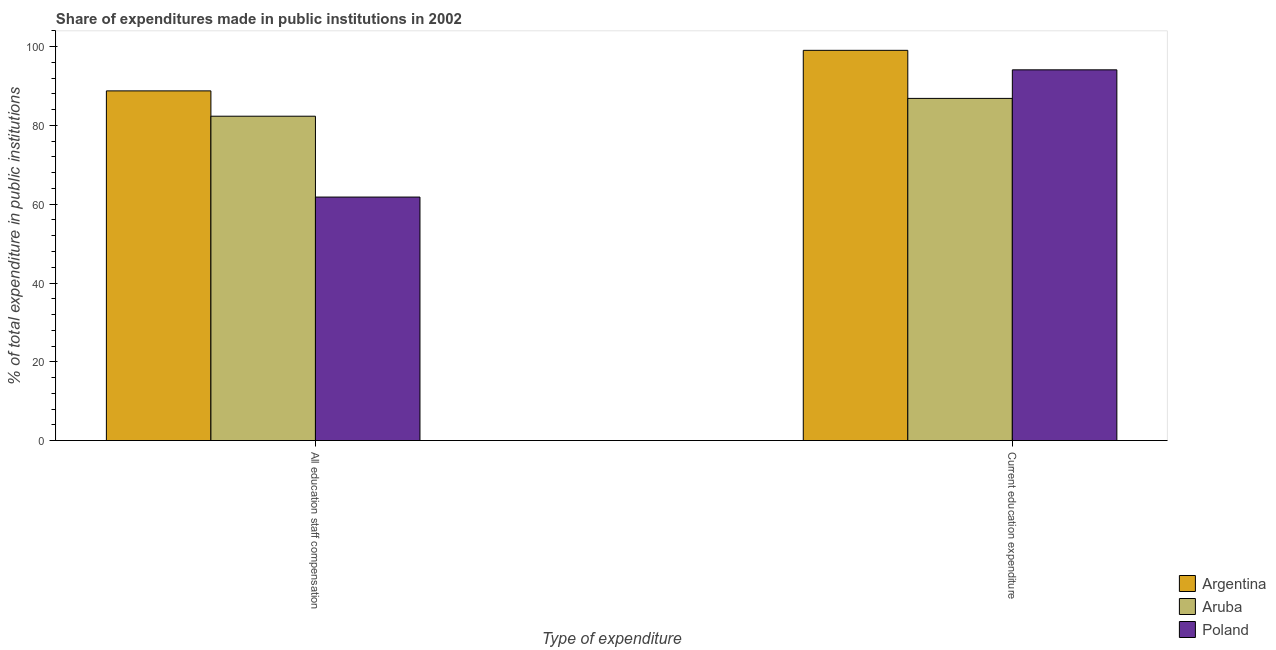How many different coloured bars are there?
Give a very brief answer. 3. How many bars are there on the 1st tick from the right?
Provide a short and direct response. 3. What is the label of the 2nd group of bars from the left?
Ensure brevity in your answer.  Current education expenditure. What is the expenditure in education in Argentina?
Ensure brevity in your answer.  99.06. Across all countries, what is the maximum expenditure in staff compensation?
Give a very brief answer. 88.77. Across all countries, what is the minimum expenditure in education?
Provide a succinct answer. 86.86. In which country was the expenditure in education maximum?
Keep it short and to the point. Argentina. In which country was the expenditure in education minimum?
Give a very brief answer. Aruba. What is the total expenditure in staff compensation in the graph?
Your answer should be very brief. 232.92. What is the difference between the expenditure in staff compensation in Poland and that in Argentina?
Give a very brief answer. -26.95. What is the difference between the expenditure in education in Poland and the expenditure in staff compensation in Aruba?
Make the answer very short. 11.77. What is the average expenditure in education per country?
Offer a very short reply. 93.34. What is the difference between the expenditure in staff compensation and expenditure in education in Argentina?
Your answer should be compact. -10.29. In how many countries, is the expenditure in education greater than 76 %?
Offer a terse response. 3. What is the ratio of the expenditure in education in Aruba to that in Argentina?
Your answer should be compact. 0.88. What does the 2nd bar from the right in Current education expenditure represents?
Your answer should be very brief. Aruba. How many bars are there?
Make the answer very short. 6. Are all the bars in the graph horizontal?
Your answer should be compact. No. What is the difference between two consecutive major ticks on the Y-axis?
Make the answer very short. 20. Are the values on the major ticks of Y-axis written in scientific E-notation?
Provide a succinct answer. No. How many legend labels are there?
Offer a terse response. 3. How are the legend labels stacked?
Make the answer very short. Vertical. What is the title of the graph?
Your response must be concise. Share of expenditures made in public institutions in 2002. What is the label or title of the X-axis?
Offer a very short reply. Type of expenditure. What is the label or title of the Y-axis?
Provide a succinct answer. % of total expenditure in public institutions. What is the % of total expenditure in public institutions of Argentina in All education staff compensation?
Make the answer very short. 88.77. What is the % of total expenditure in public institutions of Aruba in All education staff compensation?
Ensure brevity in your answer.  82.34. What is the % of total expenditure in public institutions in Poland in All education staff compensation?
Provide a short and direct response. 61.81. What is the % of total expenditure in public institutions in Argentina in Current education expenditure?
Your answer should be compact. 99.06. What is the % of total expenditure in public institutions in Aruba in Current education expenditure?
Your answer should be compact. 86.86. What is the % of total expenditure in public institutions of Poland in Current education expenditure?
Offer a terse response. 94.11. Across all Type of expenditure, what is the maximum % of total expenditure in public institutions in Argentina?
Your answer should be very brief. 99.06. Across all Type of expenditure, what is the maximum % of total expenditure in public institutions of Aruba?
Provide a succinct answer. 86.86. Across all Type of expenditure, what is the maximum % of total expenditure in public institutions in Poland?
Give a very brief answer. 94.11. Across all Type of expenditure, what is the minimum % of total expenditure in public institutions in Argentina?
Provide a short and direct response. 88.77. Across all Type of expenditure, what is the minimum % of total expenditure in public institutions of Aruba?
Give a very brief answer. 82.34. Across all Type of expenditure, what is the minimum % of total expenditure in public institutions of Poland?
Ensure brevity in your answer.  61.81. What is the total % of total expenditure in public institutions of Argentina in the graph?
Ensure brevity in your answer.  187.83. What is the total % of total expenditure in public institutions of Aruba in the graph?
Keep it short and to the point. 169.2. What is the total % of total expenditure in public institutions of Poland in the graph?
Offer a very short reply. 155.93. What is the difference between the % of total expenditure in public institutions of Argentina in All education staff compensation and that in Current education expenditure?
Keep it short and to the point. -10.29. What is the difference between the % of total expenditure in public institutions of Aruba in All education staff compensation and that in Current education expenditure?
Your answer should be compact. -4.52. What is the difference between the % of total expenditure in public institutions of Poland in All education staff compensation and that in Current education expenditure?
Give a very brief answer. -32.3. What is the difference between the % of total expenditure in public institutions in Argentina in All education staff compensation and the % of total expenditure in public institutions in Aruba in Current education expenditure?
Give a very brief answer. 1.91. What is the difference between the % of total expenditure in public institutions of Argentina in All education staff compensation and the % of total expenditure in public institutions of Poland in Current education expenditure?
Provide a short and direct response. -5.34. What is the difference between the % of total expenditure in public institutions in Aruba in All education staff compensation and the % of total expenditure in public institutions in Poland in Current education expenditure?
Give a very brief answer. -11.77. What is the average % of total expenditure in public institutions of Argentina per Type of expenditure?
Keep it short and to the point. 93.91. What is the average % of total expenditure in public institutions of Aruba per Type of expenditure?
Provide a short and direct response. 84.6. What is the average % of total expenditure in public institutions in Poland per Type of expenditure?
Provide a succinct answer. 77.96. What is the difference between the % of total expenditure in public institutions of Argentina and % of total expenditure in public institutions of Aruba in All education staff compensation?
Provide a succinct answer. 6.43. What is the difference between the % of total expenditure in public institutions of Argentina and % of total expenditure in public institutions of Poland in All education staff compensation?
Your answer should be compact. 26.95. What is the difference between the % of total expenditure in public institutions of Aruba and % of total expenditure in public institutions of Poland in All education staff compensation?
Your answer should be compact. 20.53. What is the difference between the % of total expenditure in public institutions in Argentina and % of total expenditure in public institutions in Aruba in Current education expenditure?
Your answer should be very brief. 12.2. What is the difference between the % of total expenditure in public institutions of Argentina and % of total expenditure in public institutions of Poland in Current education expenditure?
Provide a short and direct response. 4.95. What is the difference between the % of total expenditure in public institutions in Aruba and % of total expenditure in public institutions in Poland in Current education expenditure?
Give a very brief answer. -7.25. What is the ratio of the % of total expenditure in public institutions in Argentina in All education staff compensation to that in Current education expenditure?
Your answer should be compact. 0.9. What is the ratio of the % of total expenditure in public institutions in Aruba in All education staff compensation to that in Current education expenditure?
Provide a succinct answer. 0.95. What is the ratio of the % of total expenditure in public institutions of Poland in All education staff compensation to that in Current education expenditure?
Your answer should be compact. 0.66. What is the difference between the highest and the second highest % of total expenditure in public institutions in Argentina?
Give a very brief answer. 10.29. What is the difference between the highest and the second highest % of total expenditure in public institutions in Aruba?
Your response must be concise. 4.52. What is the difference between the highest and the second highest % of total expenditure in public institutions of Poland?
Your answer should be compact. 32.3. What is the difference between the highest and the lowest % of total expenditure in public institutions of Argentina?
Your response must be concise. 10.29. What is the difference between the highest and the lowest % of total expenditure in public institutions in Aruba?
Keep it short and to the point. 4.52. What is the difference between the highest and the lowest % of total expenditure in public institutions in Poland?
Ensure brevity in your answer.  32.3. 